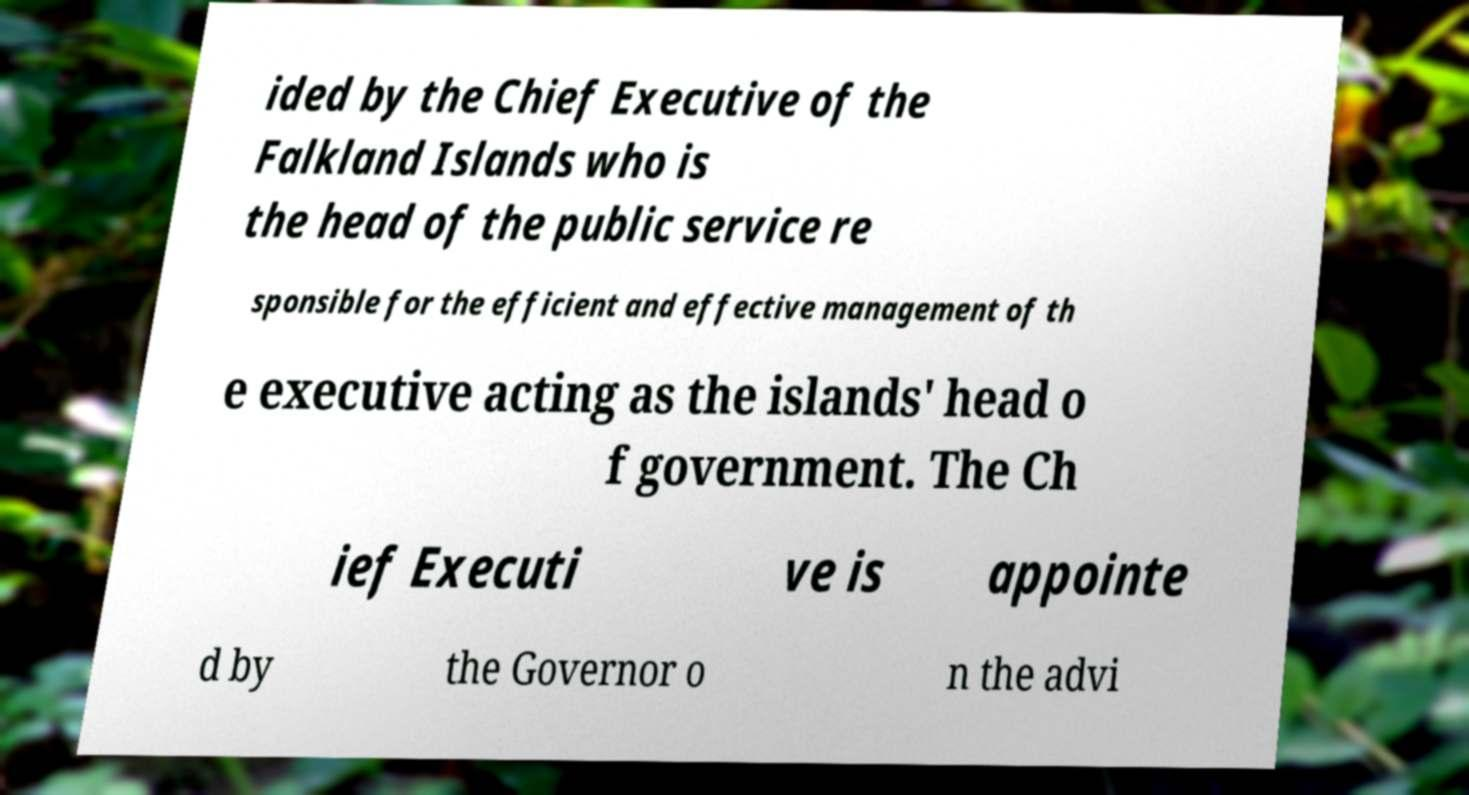Can you accurately transcribe the text from the provided image for me? ided by the Chief Executive of the Falkland Islands who is the head of the public service re sponsible for the efficient and effective management of th e executive acting as the islands' head o f government. The Ch ief Executi ve is appointe d by the Governor o n the advi 